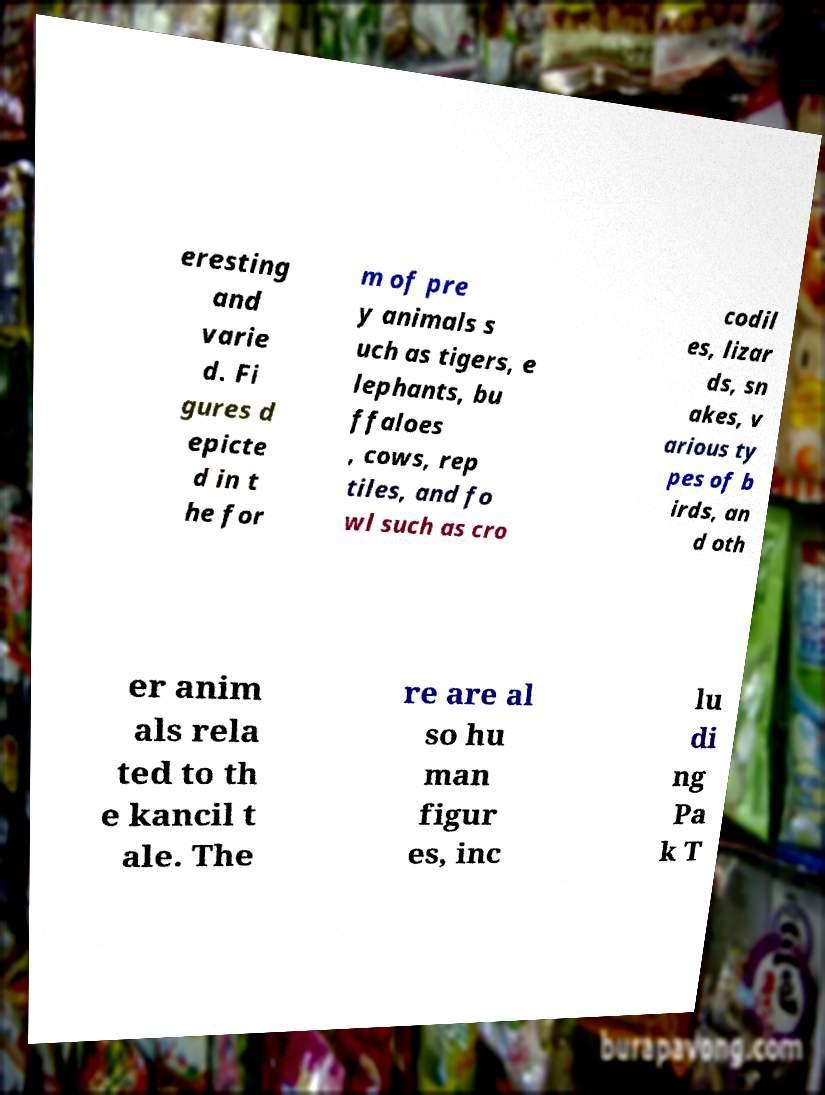Could you assist in decoding the text presented in this image and type it out clearly? eresting and varie d. Fi gures d epicte d in t he for m of pre y animals s uch as tigers, e lephants, bu ffaloes , cows, rep tiles, and fo wl such as cro codil es, lizar ds, sn akes, v arious ty pes of b irds, an d oth er anim als rela ted to th e kancil t ale. The re are al so hu man figur es, inc lu di ng Pa k T 